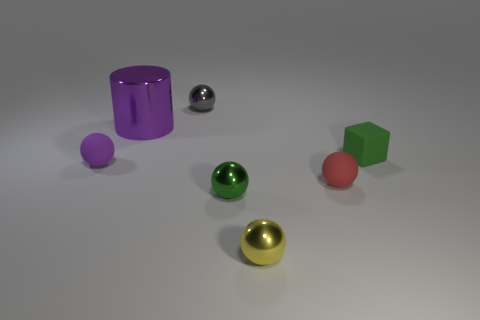There is a shiny sphere that is the same color as the matte block; what is its size?
Offer a very short reply. Small. There is a green thing that is in front of the rubber sphere that is right of the purple shiny object; what is its shape?
Ensure brevity in your answer.  Sphere. There is a purple object behind the tiny rubber sphere left of the small yellow object; is there a tiny ball that is left of it?
Your answer should be compact. Yes. What color is the block that is the same size as the purple matte sphere?
Ensure brevity in your answer.  Green. There is a thing that is both behind the small purple matte thing and in front of the purple metallic object; what shape is it?
Provide a succinct answer. Cube. There is a sphere to the right of the sphere in front of the green ball; how big is it?
Your response must be concise. Small. How many other shiny cylinders are the same color as the large cylinder?
Your answer should be very brief. 0. How many other things are there of the same size as the gray metallic thing?
Your answer should be very brief. 5. How big is the sphere that is behind the tiny green ball and to the right of the small gray object?
Your answer should be very brief. Small. How many tiny cyan shiny things have the same shape as the tiny red object?
Keep it short and to the point. 0. 